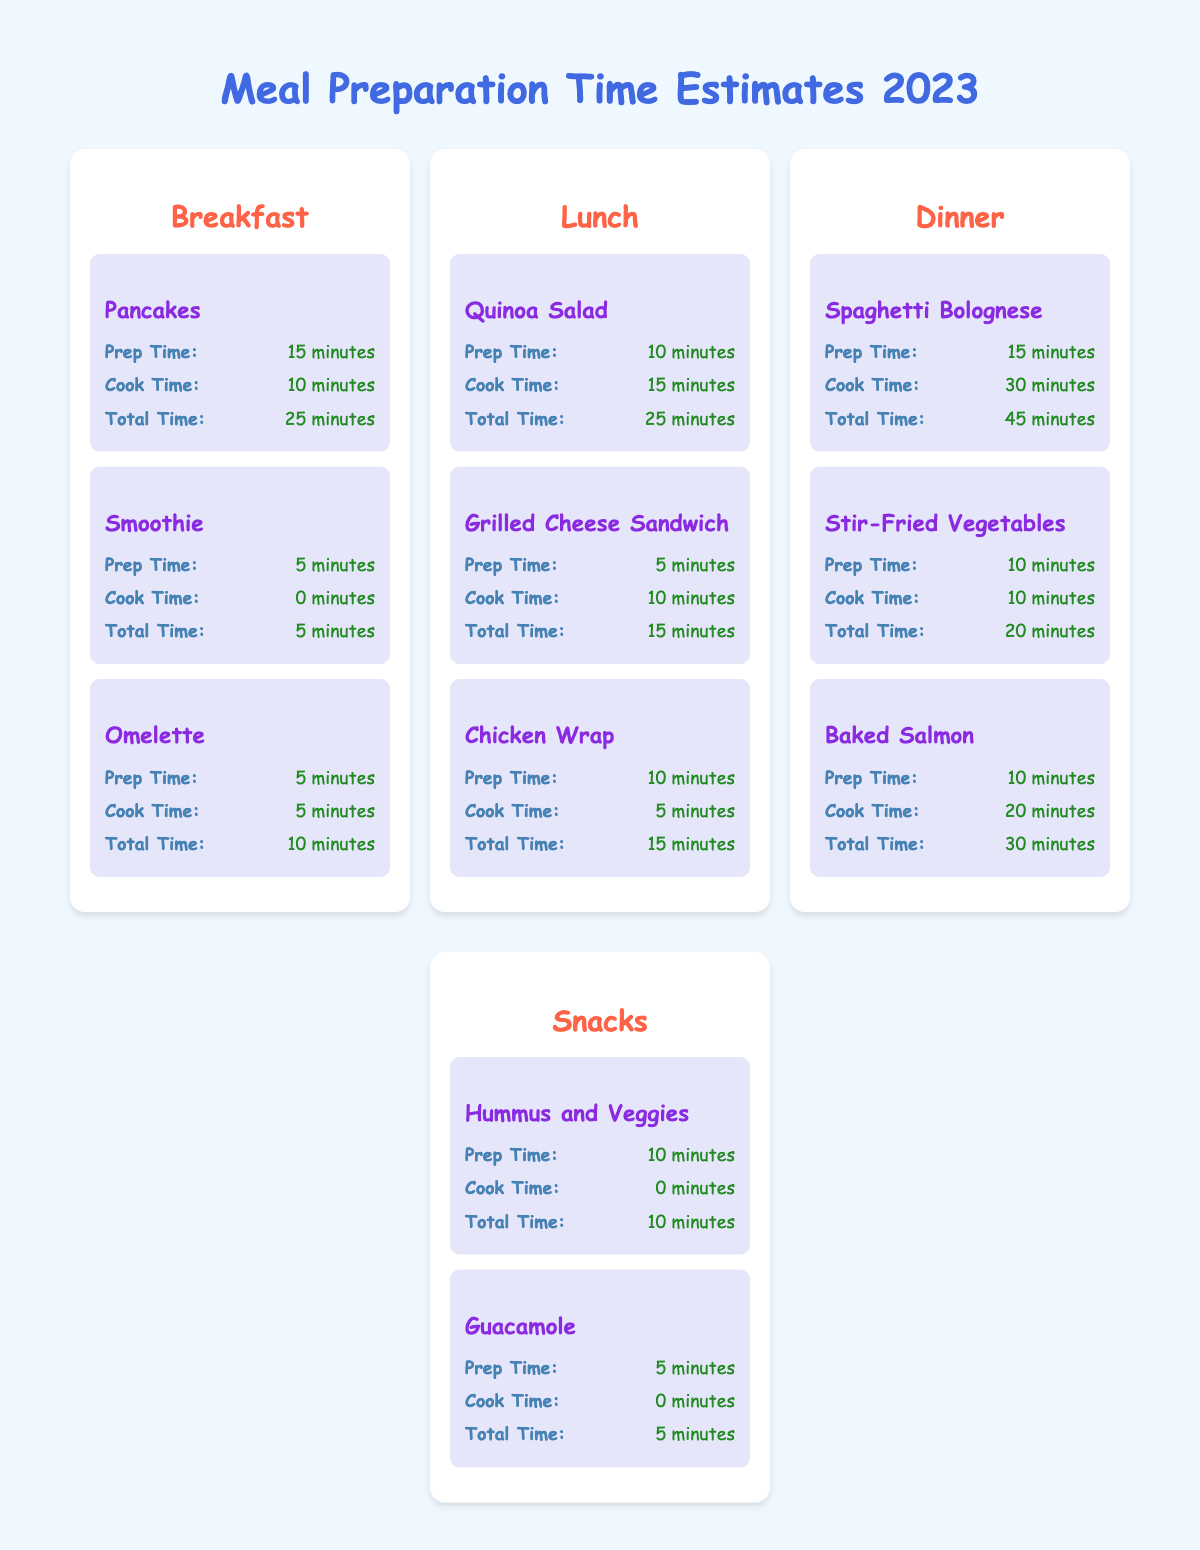What is the total time for making a Pancake? The table shows that the total time for making a Pancake is explicitly listed. By checking the information under the "Pancakes" recipe in the "Breakfast" section, we can see that the total time is 25 minutes.
Answer: 25 minutes Which recipe takes the least amount of time to prepare? To determine which recipe takes the least amount of time, we compare the total times of all recipes listed in the table. The "Smoothie" recipe in the "Breakfast" section has a total time of 5 minutes, making it the quickest option.
Answer: Smoothie How much longer does it take to cook Spaghetti Bolognese than to make a Grilled Cheese Sandwich? We need to find the cook times for both recipes first. For Spaghetti Bolognese, the cook time is 30 minutes, and for Grilled Cheese Sandwich, it is 10 minutes. The difference is calculated as 30 - 10 = 20 minutes, indicating it takes 20 minutes longer to cook Spaghetti Bolognese.
Answer: 20 minutes Is the total preparation time for any snack 10 minutes? Looking at the snacks section of the table, we see two options: "Hummus and Veggies" which has a prep time of 10 minutes and "Guacamole" which has a prep time of 5 minutes. Therefore, there is indeed a snack recipe that has a prep time of 10 minutes, making the statement true.
Answer: Yes What is the average total time for lunch recipes? First, gather the total times for each lunch recipe: Quinoa Salad is 25 minutes, Grilled Cheese Sandwich is 15 minutes, and Chicken Wrap is also 15 minutes. We add these together: 25 + 15 + 15 = 55 minutes. Then, we divide by the number of recipes, which is 3: 55 / 3 = 18.33 minutes. Thus, the average total time for lunch recipes is about 18.33 minutes.
Answer: 18.33 minutes How long does it take to prepare a Baked Salmon? Checking the information provided under the "Baked Salmon" recipe in the "Dinner" section, we find the prep time listed as 10 minutes.
Answer: 10 minutes Which meal type has the shortest overall cooking time? To determine this, we check the total cooking times for each meal type: Breakfast (Total: 25 minutes), Lunch (Total: 40 minutes), Dinner (Total: 60 minutes), Snacks (Total: 15 minutes). The "Breakfast" category has the lowest total time at 25 minutes compared to others.
Answer: Breakfast Are there any meals that require a total time of less than 15 minutes? By examining each recipe's total time in the table, we find that both "Smoothie" (5 minutes) and "Grilled Cheese Sandwich" (15 minutes) have times that fit under 15 minutes. Thus, the answer is yes.
Answer: Yes 